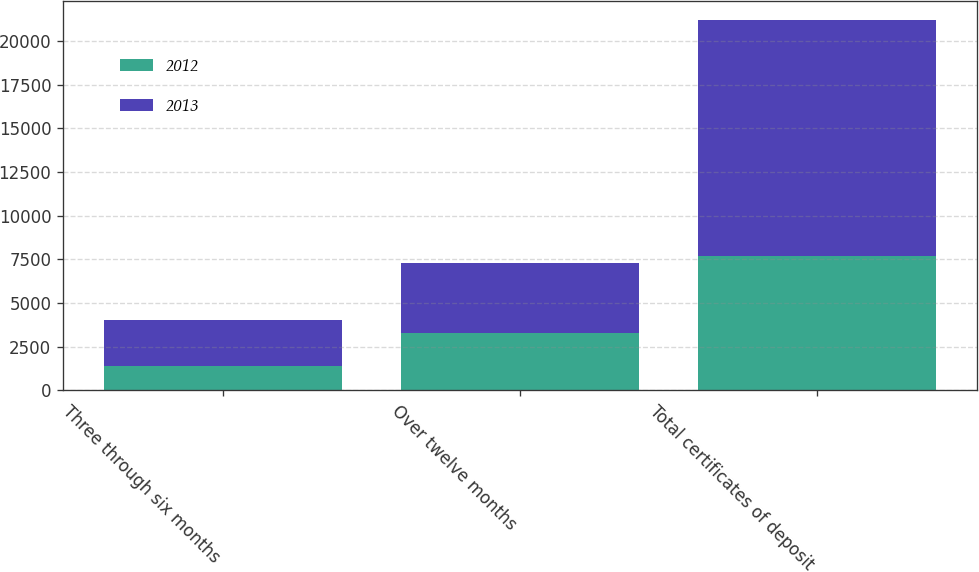Convert chart. <chart><loc_0><loc_0><loc_500><loc_500><stacked_bar_chart><ecel><fcel>Three through six months<fcel>Over twelve months<fcel>Total certificates of deposit<nl><fcel>2012<fcel>1384<fcel>3294<fcel>7702<nl><fcel>2013<fcel>2666<fcel>4019<fcel>13518<nl></chart> 